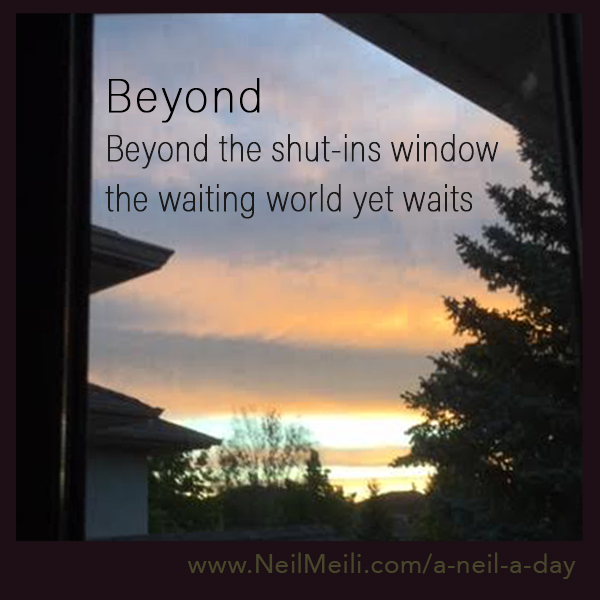Imagine you are a bird flying in this scene. What do you see? As a bird flying in this scene, I see the world from above, the trees swaying gently with the morning or evening breeze. Houses with silent roofs and streets empty but full of stories. The sky is a canvas of warm hues, casting a golden glow on everything below. I witness the beauty of the horizon stretching endlessly, inviting me to explore new heights and distant lands. 